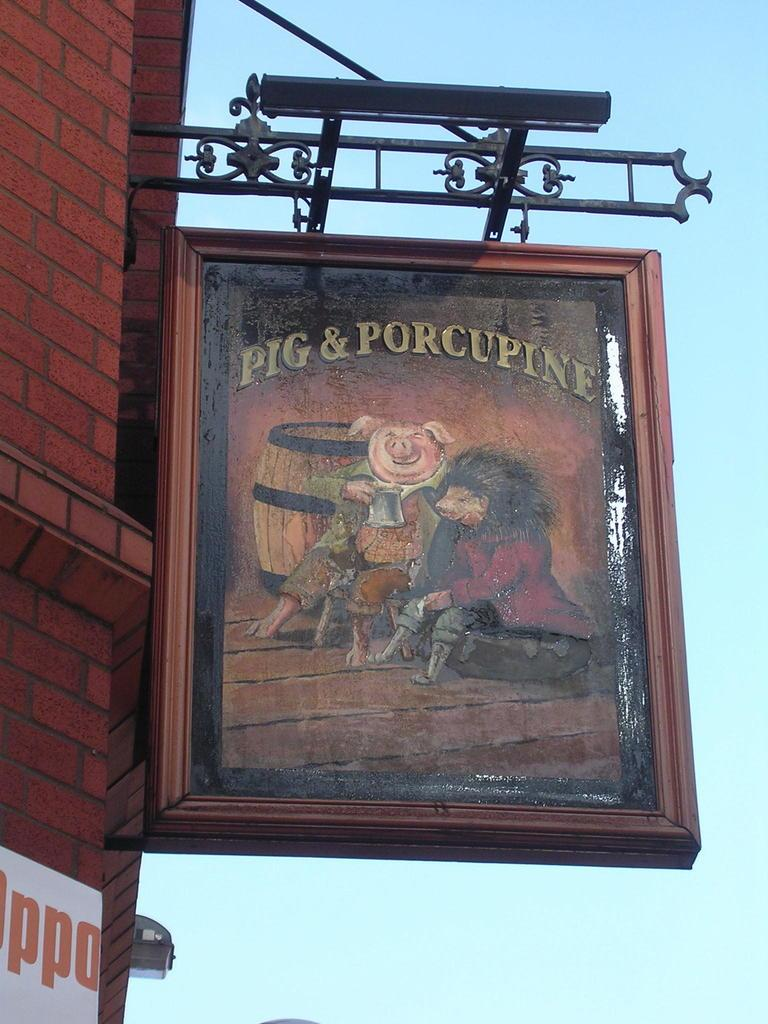<image>
Provide a brief description of the given image. A sign board that reads Pig & Porcupine 